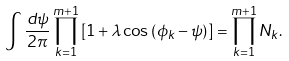<formula> <loc_0><loc_0><loc_500><loc_500>\int \frac { d \psi } { 2 \pi } \prod _ { k = 1 } ^ { m + 1 } \left [ 1 + \lambda \cos \left ( \phi _ { k } - \psi \right ) \right ] = \prod _ { k = 1 } ^ { m + 1 } N _ { k } .</formula> 